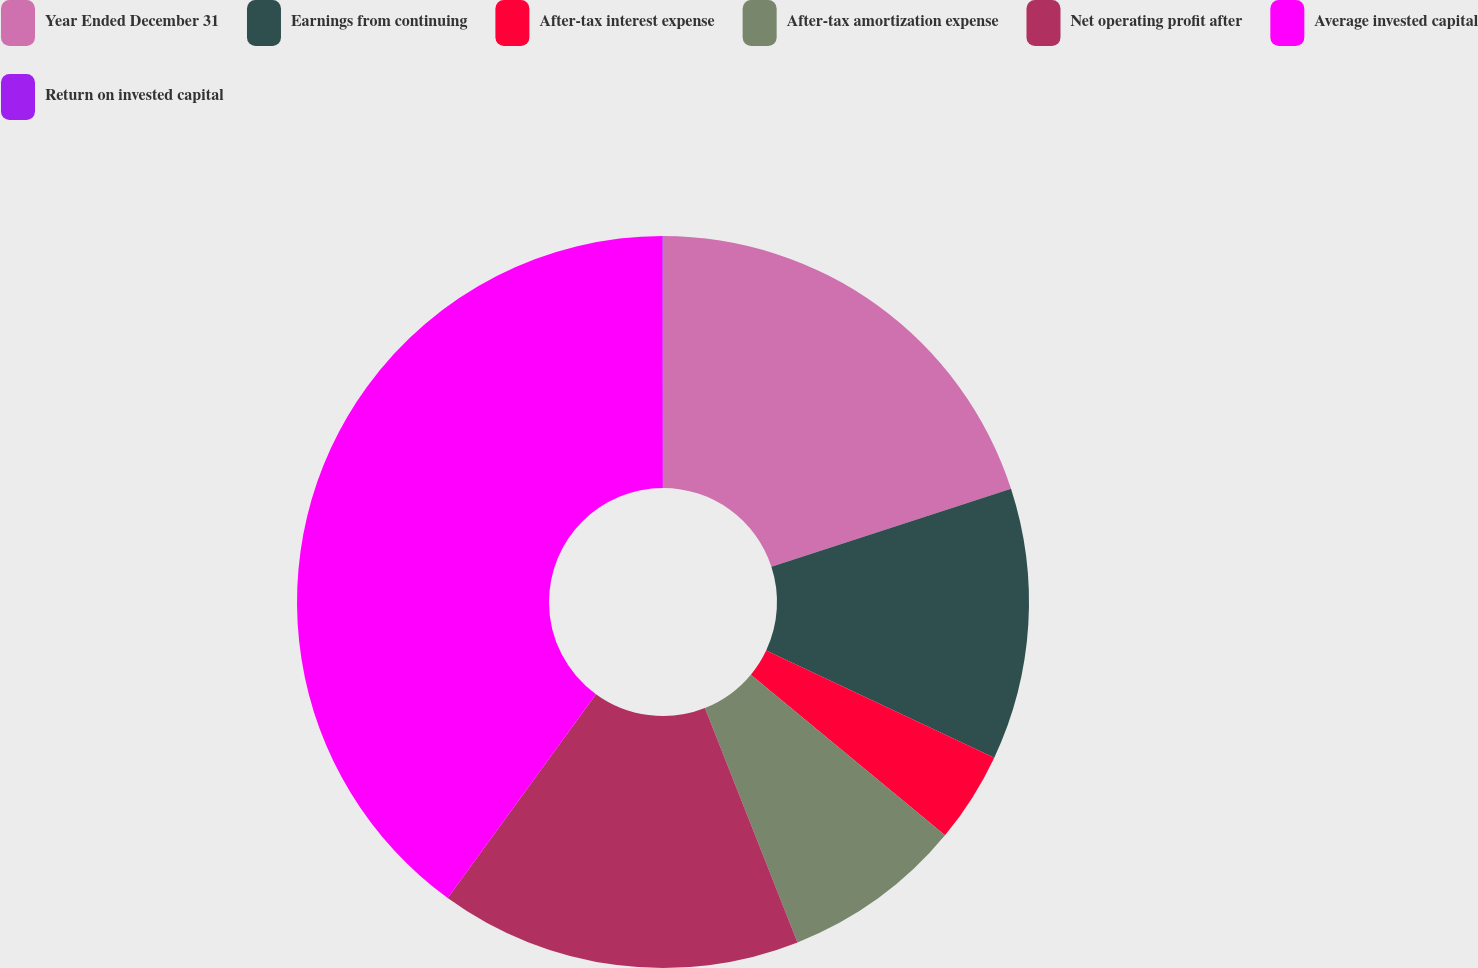Convert chart to OTSL. <chart><loc_0><loc_0><loc_500><loc_500><pie_chart><fcel>Year Ended December 31<fcel>Earnings from continuing<fcel>After-tax interest expense<fcel>After-tax amortization expense<fcel>Net operating profit after<fcel>Average invested capital<fcel>Return on invested capital<nl><fcel>19.99%<fcel>12.0%<fcel>4.01%<fcel>8.01%<fcel>16.0%<fcel>39.97%<fcel>0.02%<nl></chart> 